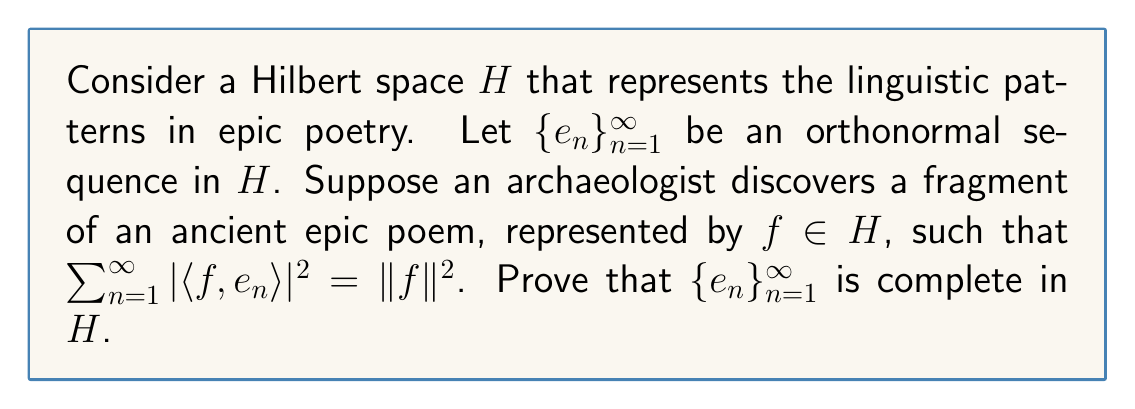Help me with this question. To prove that $\{e_n\}_{n=1}^{\infty}$ is complete in $H$, we need to show that the span of $\{e_n\}_{n=1}^{\infty}$ is dense in $H$. We'll use the following steps:

1) First, recall Parseval's identity for a complete orthonormal sequence:

   $$\sum_{n=1}^{\infty} |\langle f, e_n \rangle|^2 = \|f\|^2$$

   This is given in the problem statement, suggesting that $\{e_n\}_{n=1}^{\infty}$ might be complete.

2) To prove completeness, we'll show that the only element orthogonal to all $e_n$ is the zero vector.

3) Let $g \in H$ be orthogonal to all $e_n$. This means:

   $$\langle g, e_n \rangle = 0 \quad \text{for all } n \in \mathbb{N}$$

4) Now, consider $f = g$ in the given equation:

   $$\sum_{n=1}^{\infty} |\langle g, e_n \rangle|^2 = \|g\|^2$$

5) But since $\langle g, e_n \rangle = 0$ for all $n$, the left side of this equation is zero:

   $$0 = \|g\|^2$$

6) This implies that $g = 0$, as the norm of a vector is zero if and only if the vector itself is zero.

7) We have shown that the only vector orthogonal to all $e_n$ is the zero vector. By the Projection Theorem in Hilbert spaces, this implies that the span of $\{e_n\}_{n=1}^{\infty}$ is dense in $H$.

Therefore, $\{e_n\}_{n=1}^{\infty}$ is complete in $H$.
Answer: The orthonormal sequence $\{e_n\}_{n=1}^{\infty}$ is complete in the Hilbert space $H$. 